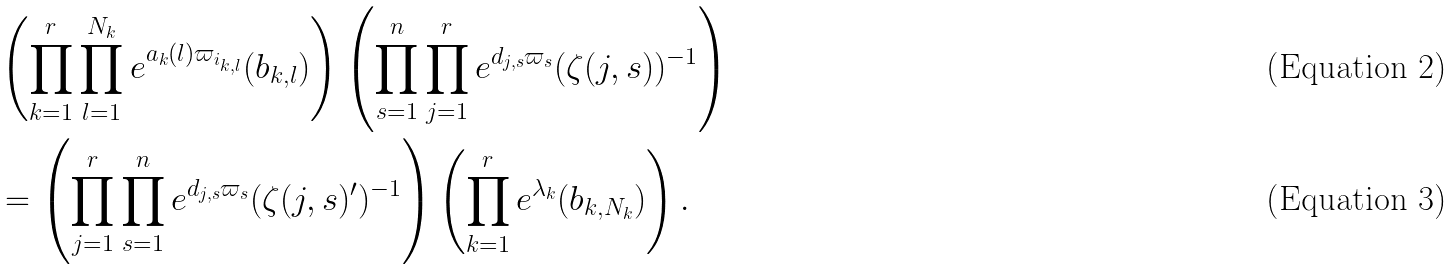<formula> <loc_0><loc_0><loc_500><loc_500>& \left ( \prod _ { k = 1 } ^ { r } \prod _ { l = 1 } ^ { N _ { k } } e ^ { a _ { k } ( l ) \varpi _ { i _ { k , l } } } ( b _ { k , l } ) \right ) \left ( \prod _ { s = 1 } ^ { n } \prod _ { j = 1 } ^ { r } e ^ { d _ { j , s } \varpi _ { s } } ( \zeta ( j , s ) ) ^ { - 1 } \right ) \\ & = \left ( \prod _ { j = 1 } ^ { r } \prod _ { s = 1 } ^ { n } e ^ { d _ { j , s } \varpi _ { s } } ( \zeta ( j , s ) ^ { \prime } ) ^ { - 1 } \right ) \left ( \prod _ { k = 1 } ^ { r } e ^ { \lambda _ { k } } ( b _ { k , N _ { k } } ) \right ) .</formula> 